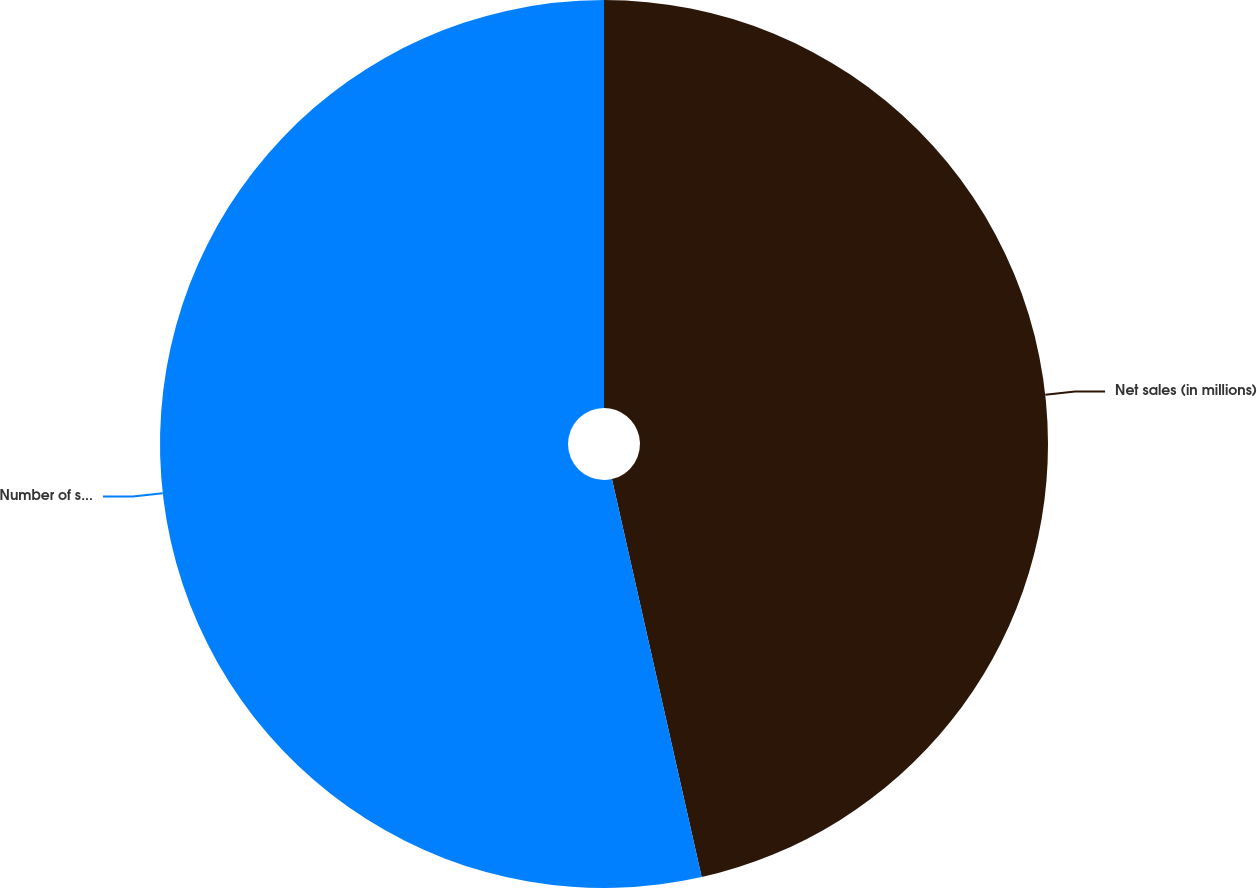Convert chart. <chart><loc_0><loc_0><loc_500><loc_500><pie_chart><fcel>Net sales (in millions)<fcel>Number of stores<nl><fcel>46.47%<fcel>53.53%<nl></chart> 